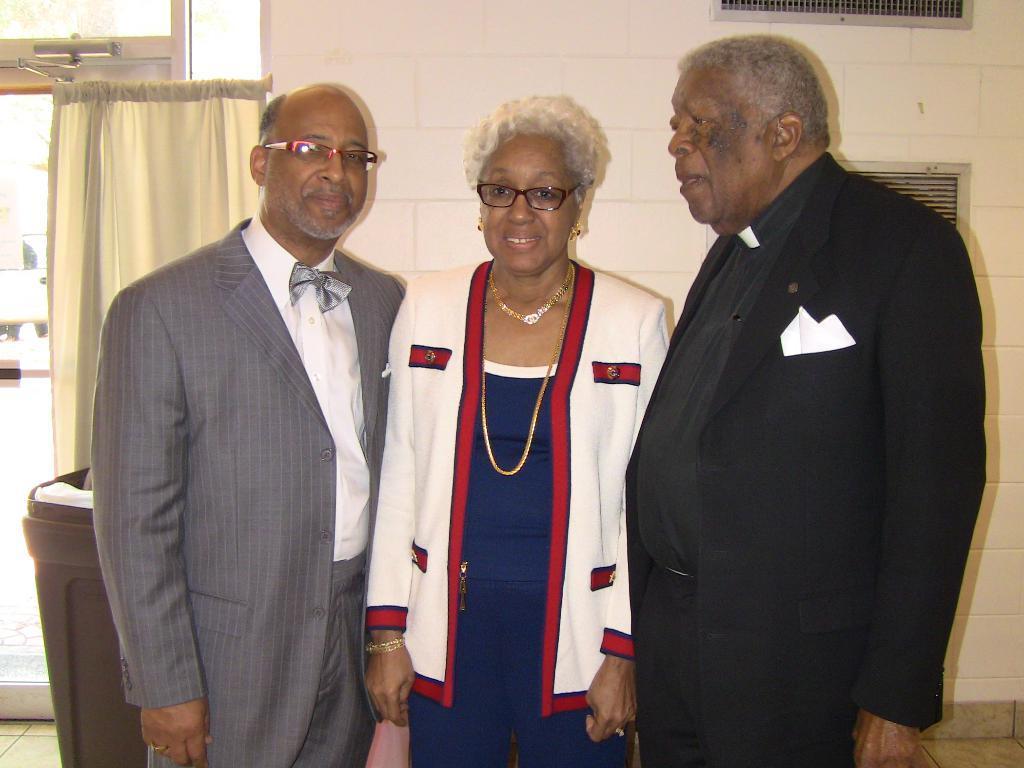Could you give a brief overview of what you see in this image? In this picture, we see two men and a woman are standing. They are smiling and they are posing for the photo. Behind them, we see a garbage bin and behind that, we see a curtain in white color. On the left side, we see the glass doors from which we can see the buildings. In the background, we see a wall in white color. 